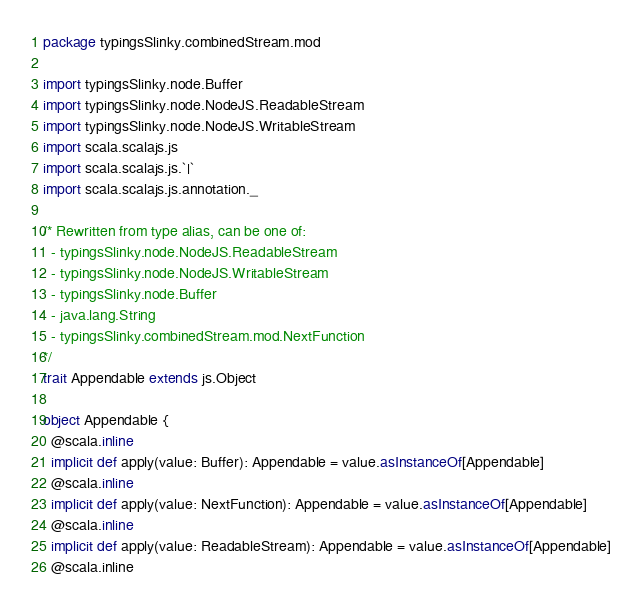Convert code to text. <code><loc_0><loc_0><loc_500><loc_500><_Scala_>package typingsSlinky.combinedStream.mod

import typingsSlinky.node.Buffer
import typingsSlinky.node.NodeJS.ReadableStream
import typingsSlinky.node.NodeJS.WritableStream
import scala.scalajs.js
import scala.scalajs.js.`|`
import scala.scalajs.js.annotation._

/* Rewritten from type alias, can be one of: 
  - typingsSlinky.node.NodeJS.ReadableStream
  - typingsSlinky.node.NodeJS.WritableStream
  - typingsSlinky.node.Buffer
  - java.lang.String
  - typingsSlinky.combinedStream.mod.NextFunction
*/
trait Appendable extends js.Object

object Appendable {
  @scala.inline
  implicit def apply(value: Buffer): Appendable = value.asInstanceOf[Appendable]
  @scala.inline
  implicit def apply(value: NextFunction): Appendable = value.asInstanceOf[Appendable]
  @scala.inline
  implicit def apply(value: ReadableStream): Appendable = value.asInstanceOf[Appendable]
  @scala.inline</code> 